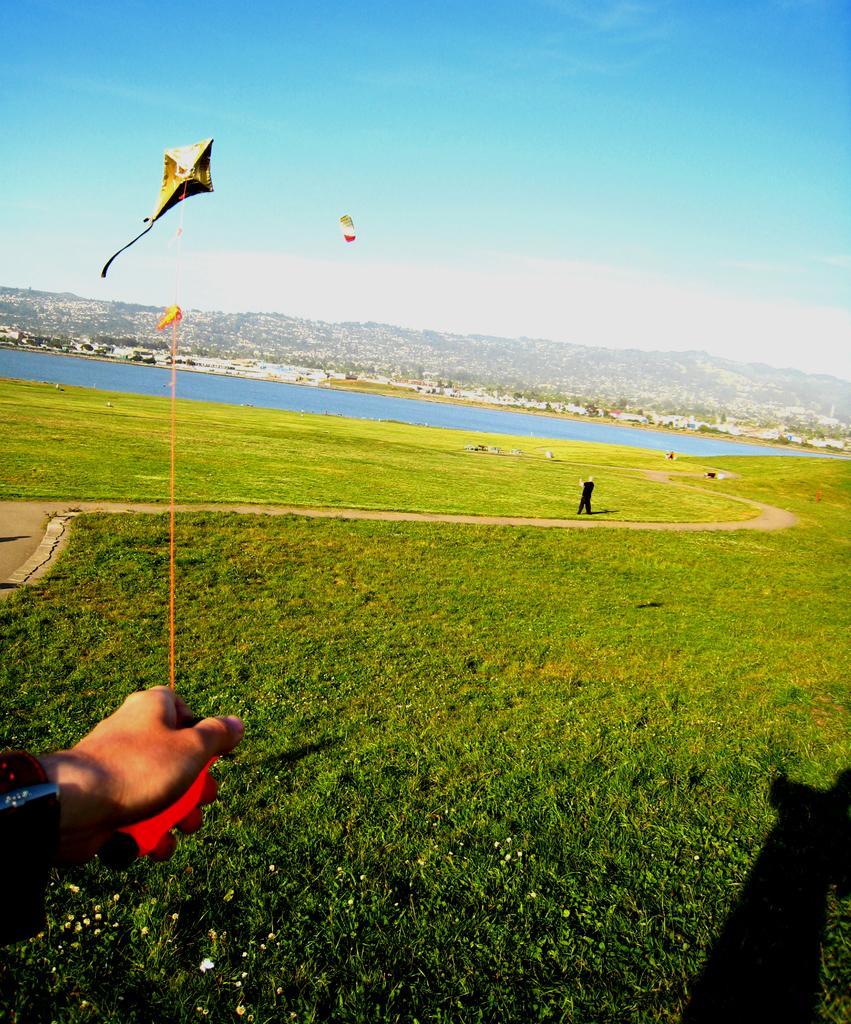In one or two sentences, can you explain what this image depicts? In this picture we can observe a human hand holding a kite which is flying in the air. There is a person standing in the ground. There is some grass on this ground. We can observe water here. In the background there are some trees and a sky. 